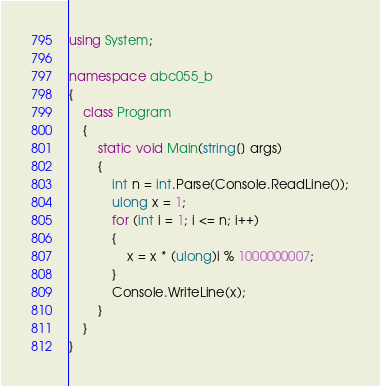Convert code to text. <code><loc_0><loc_0><loc_500><loc_500><_C#_>using System;

namespace abc055_b
{
    class Program
    {
        static void Main(string[] args)
        {
            int n = int.Parse(Console.ReadLine());
            ulong x = 1;
            for (int i = 1; i <= n; i++)
            {
                x = x * (ulong)i % 1000000007;
            }
            Console.WriteLine(x);
        }
    }
}</code> 